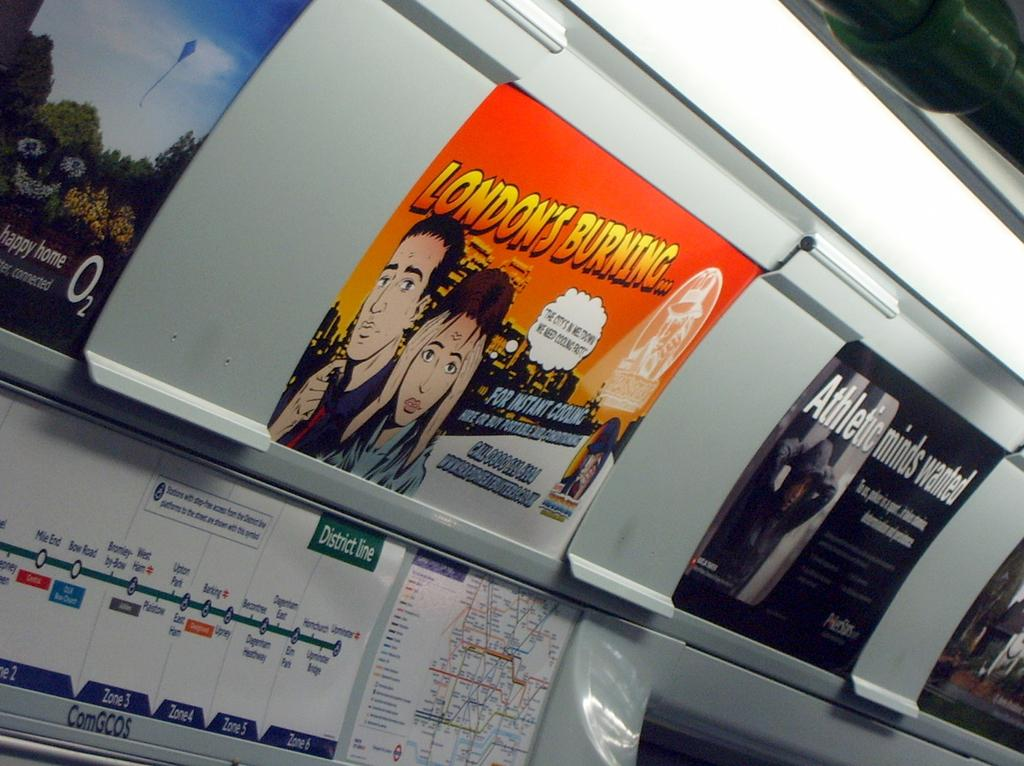<image>
Relay a brief, clear account of the picture shown. An advertisement inside of a British train car for instant cooling. 